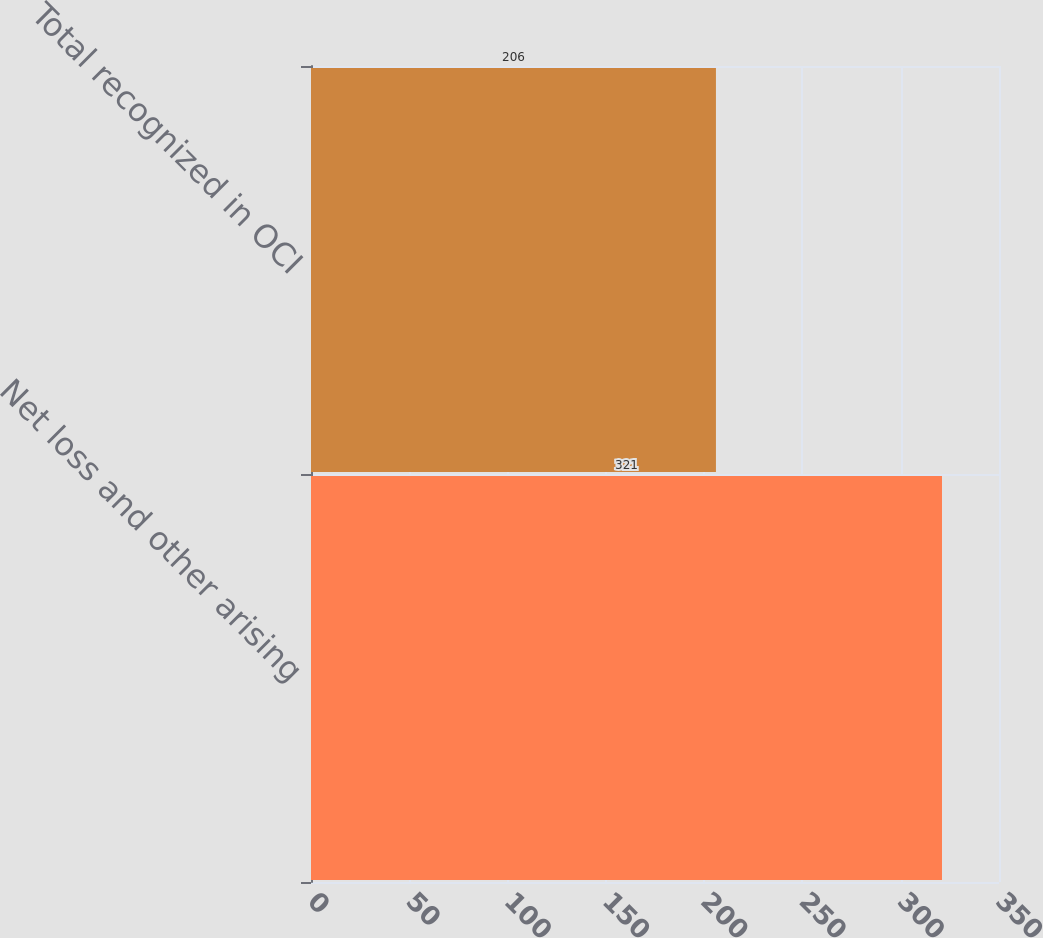<chart> <loc_0><loc_0><loc_500><loc_500><bar_chart><fcel>Net loss and other arising<fcel>Total recognized in OCI<nl><fcel>321<fcel>206<nl></chart> 